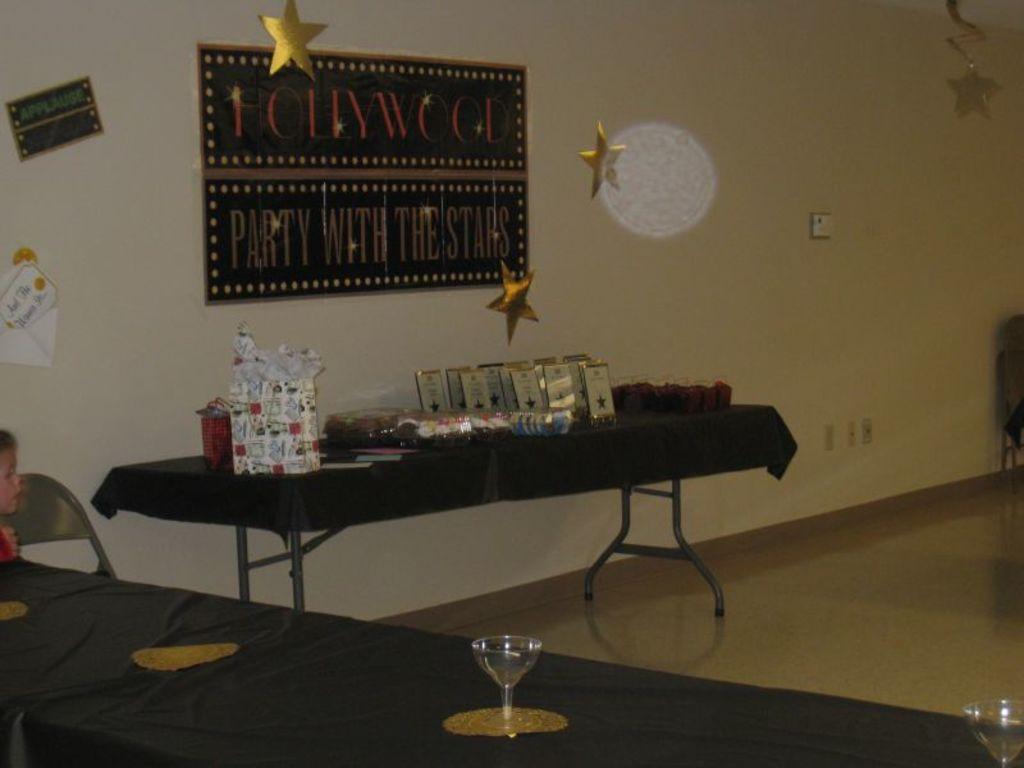How would you summarize this image in a sentence or two? This is an inside view of a room. At the bottom there is a table which is covered with a black color cloth. On the table there are two glasses. On the left side there is a person and a chair. In the middle of the image there is another table on which a box and some other objects are placed. At the top there is a board attached to the wall. In this room I can see few stars are hanging. 